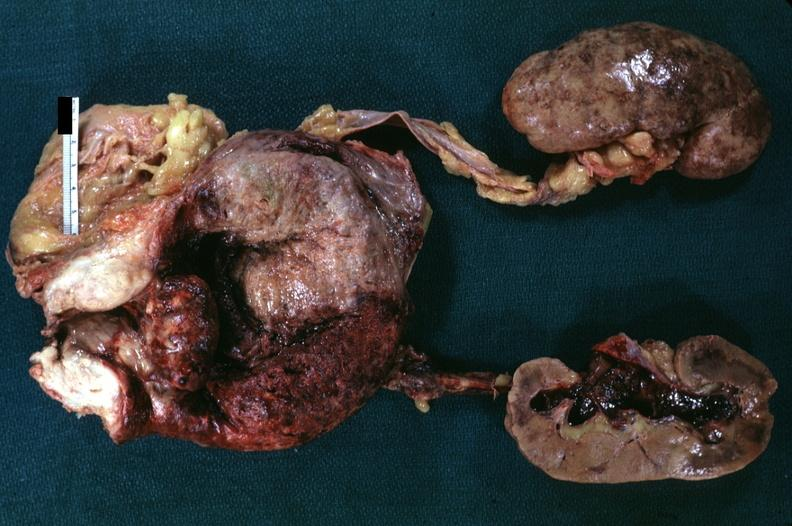what is present?
Answer the question using a single word or phrase. Prostate 